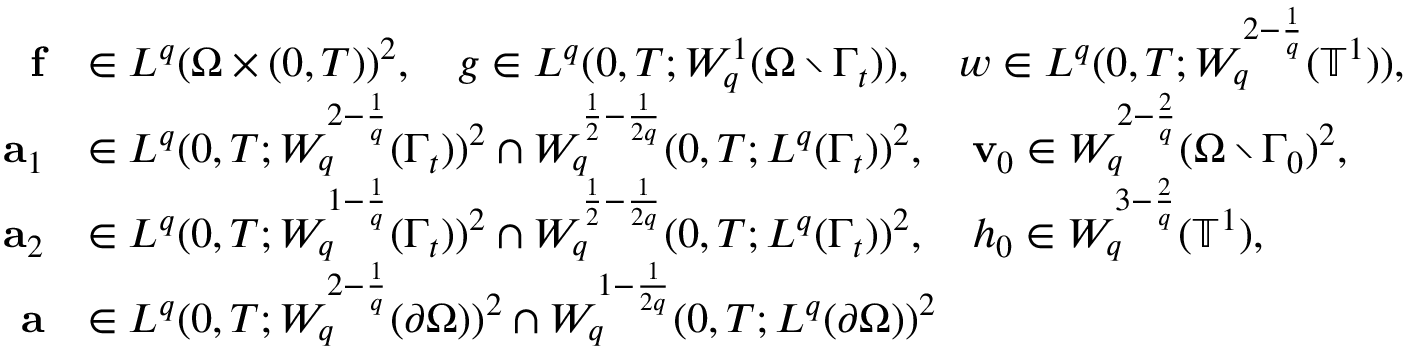Convert formula to latex. <formula><loc_0><loc_0><loc_500><loc_500>\begin{array} { r l } { f } & { \in L ^ { q } ( \Omega \times ( 0 , T ) ) ^ { 2 } , \quad g \in L ^ { q } ( 0 , T ; W _ { q } ^ { 1 } ( \Omega \ \Gamma _ { t } ) ) , \quad w \in L ^ { q } ( 0 , T ; W _ { q } ^ { 2 - \frac { 1 } { q } } ( { \mathbb { T } } ^ { 1 } ) ) , } \\ { a _ { 1 } } & { \in L ^ { q } ( 0 , T ; W _ { q } ^ { 2 - \frac { 1 } { q } } ( \Gamma _ { t } ) ) ^ { 2 } \cap W _ { q } ^ { \frac { 1 } { 2 } - \frac { 1 } 2 q } } ( 0 , T ; L ^ { q } ( \Gamma _ { t } ) ) ^ { 2 } , \quad v _ { 0 } \in W _ { q } ^ { 2 - \frac { 2 } { q } } ( \Omega \ \Gamma _ { 0 } ) ^ { 2 } , } \\ { a _ { 2 } } & { \in L ^ { q } ( 0 , T ; W _ { q } ^ { 1 - \frac { 1 } { q } } ( \Gamma _ { t } ) ) ^ { 2 } \cap W _ { q } ^ { \frac { 1 } { 2 } - \frac { 1 } 2 q } } ( 0 , T ; L ^ { q } ( \Gamma _ { t } ) ) ^ { 2 } , \quad h _ { 0 } \in W _ { q } ^ { 3 - \frac { 2 } { q } } ( { \mathbb { T } } ^ { 1 } ) , } \\ { a } & { \in L ^ { q } ( 0 , T ; W _ { q } ^ { 2 - \frac { 1 } { q } } ( \partial \Omega ) ) ^ { 2 } \cap W _ { q } ^ { 1 - \frac { 1 } 2 q } } ( 0 , T ; L ^ { q } ( \partial \Omega ) ) ^ { 2 } } \end{array}</formula> 